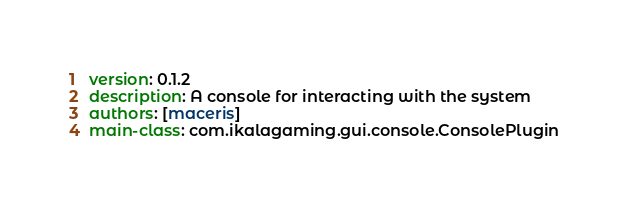Convert code to text. <code><loc_0><loc_0><loc_500><loc_500><_YAML_>version: 0.1.2
description: A console for interacting with the system
authors: [maceris]
main-class: com.ikalagaming.gui.console.ConsolePlugin
</code> 